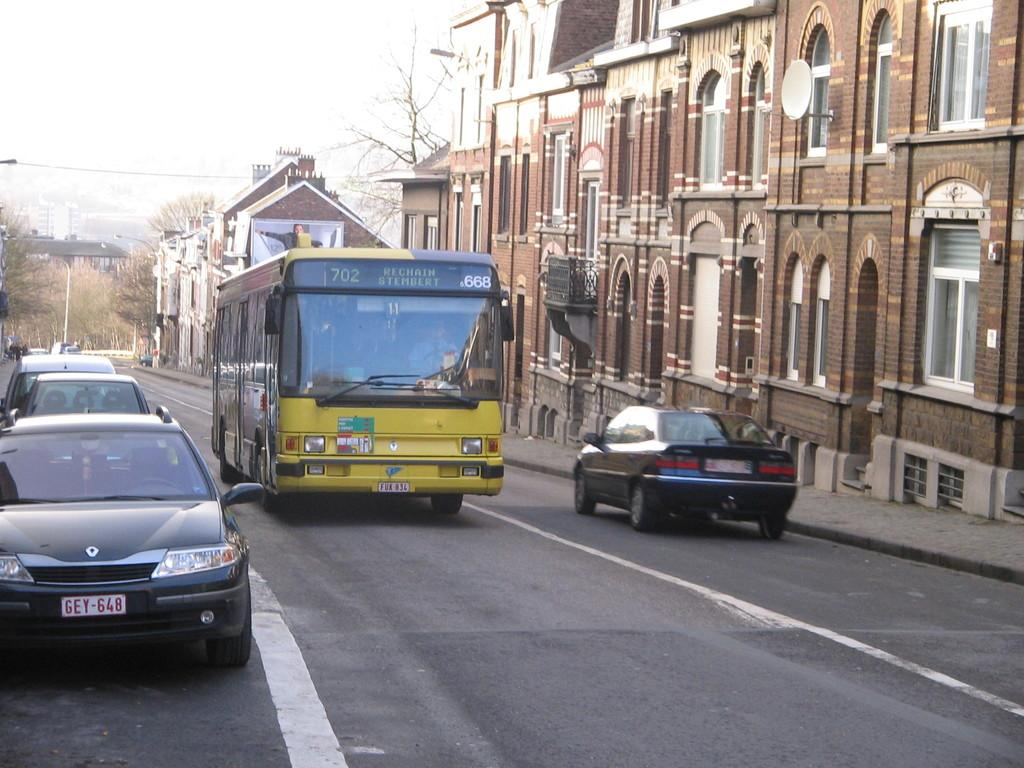<image>
Describe the image concisely. Bus that says Rechain Stembert at the top. 